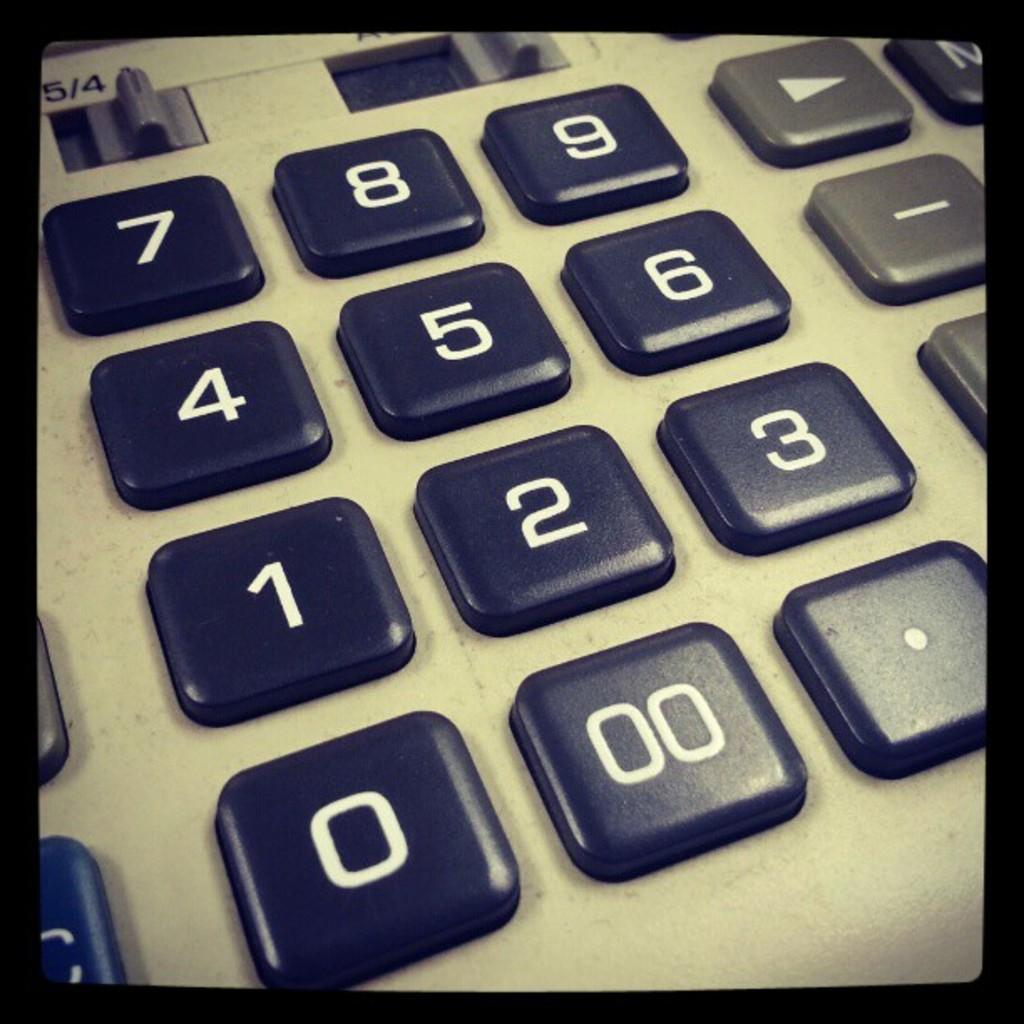Provide a one-sentence caption for the provided image. A vintage style calculator with the numbers 0-9 on it. 